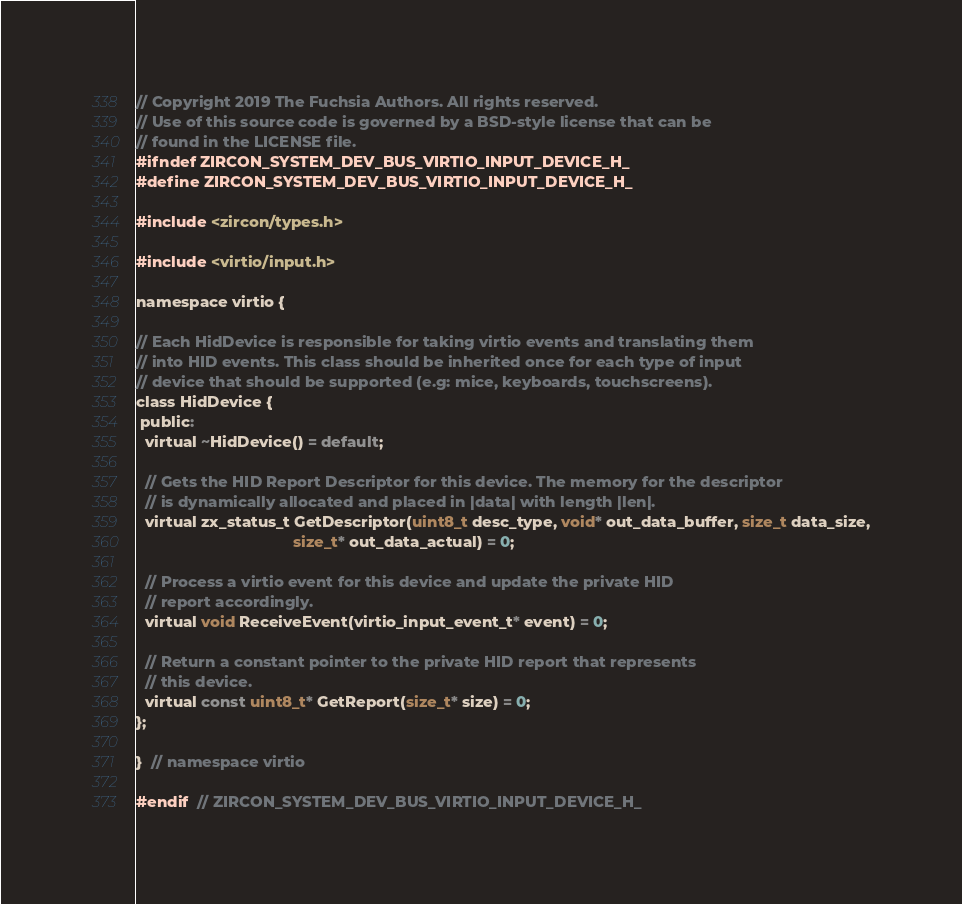<code> <loc_0><loc_0><loc_500><loc_500><_C_>// Copyright 2019 The Fuchsia Authors. All rights reserved.
// Use of this source code is governed by a BSD-style license that can be
// found in the LICENSE file.
#ifndef ZIRCON_SYSTEM_DEV_BUS_VIRTIO_INPUT_DEVICE_H_
#define ZIRCON_SYSTEM_DEV_BUS_VIRTIO_INPUT_DEVICE_H_

#include <zircon/types.h>

#include <virtio/input.h>

namespace virtio {

// Each HidDevice is responsible for taking virtio events and translating them
// into HID events. This class should be inherited once for each type of input
// device that should be supported (e.g: mice, keyboards, touchscreens).
class HidDevice {
 public:
  virtual ~HidDevice() = default;

  // Gets the HID Report Descriptor for this device. The memory for the descriptor
  // is dynamically allocated and placed in |data| with length |len|.
  virtual zx_status_t GetDescriptor(uint8_t desc_type, void* out_data_buffer, size_t data_size,
                                    size_t* out_data_actual) = 0;

  // Process a virtio event for this device and update the private HID
  // report accordingly.
  virtual void ReceiveEvent(virtio_input_event_t* event) = 0;

  // Return a constant pointer to the private HID report that represents
  // this device.
  virtual const uint8_t* GetReport(size_t* size) = 0;
};

}  // namespace virtio

#endif  // ZIRCON_SYSTEM_DEV_BUS_VIRTIO_INPUT_DEVICE_H_
</code> 